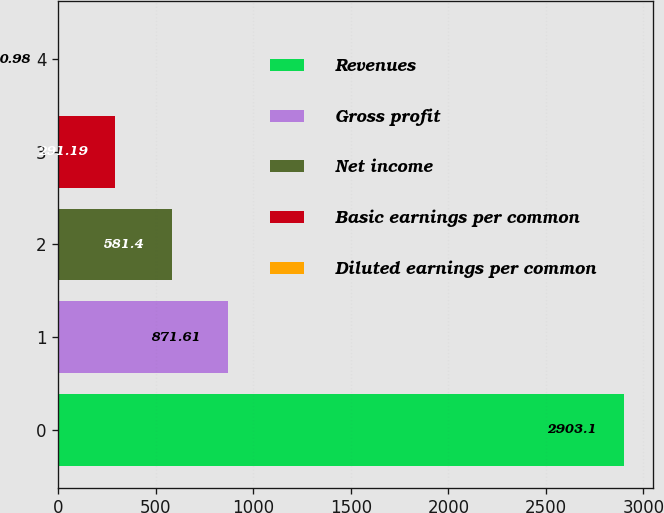Convert chart. <chart><loc_0><loc_0><loc_500><loc_500><bar_chart><fcel>Revenues<fcel>Gross profit<fcel>Net income<fcel>Basic earnings per common<fcel>Diluted earnings per common<nl><fcel>2903.1<fcel>871.61<fcel>581.4<fcel>291.19<fcel>0.98<nl></chart> 